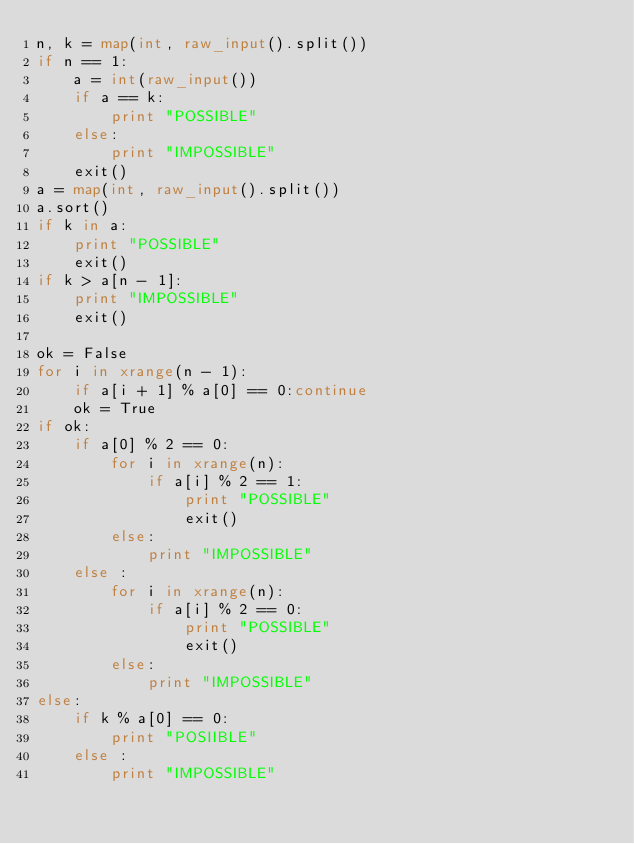Convert code to text. <code><loc_0><loc_0><loc_500><loc_500><_Python_>n, k = map(int, raw_input().split())
if n == 1:
    a = int(raw_input())
    if a == k:
        print "POSSIBLE"
    else:
        print "IMPOSSIBLE"
    exit()
a = map(int, raw_input().split())
a.sort()
if k in a:
    print "POSSIBLE"
    exit()
if k > a[n - 1]:
    print "IMPOSSIBLE"
    exit()

ok = False
for i in xrange(n - 1):
    if a[i + 1] % a[0] == 0:continue
    ok = True
if ok:
    if a[0] % 2 == 0:
        for i in xrange(n):
            if a[i] % 2 == 1:
                print "POSSIBLE"
                exit()
        else:
            print "IMPOSSIBLE"
    else :
        for i in xrange(n):
            if a[i] % 2 == 0:
                print "POSSIBLE"
                exit()
        else:
            print "IMPOSSIBLE"
else:
    if k % a[0] == 0:
        print "POSIIBLE"
    else :
        print "IMPOSSIBLE"
</code> 